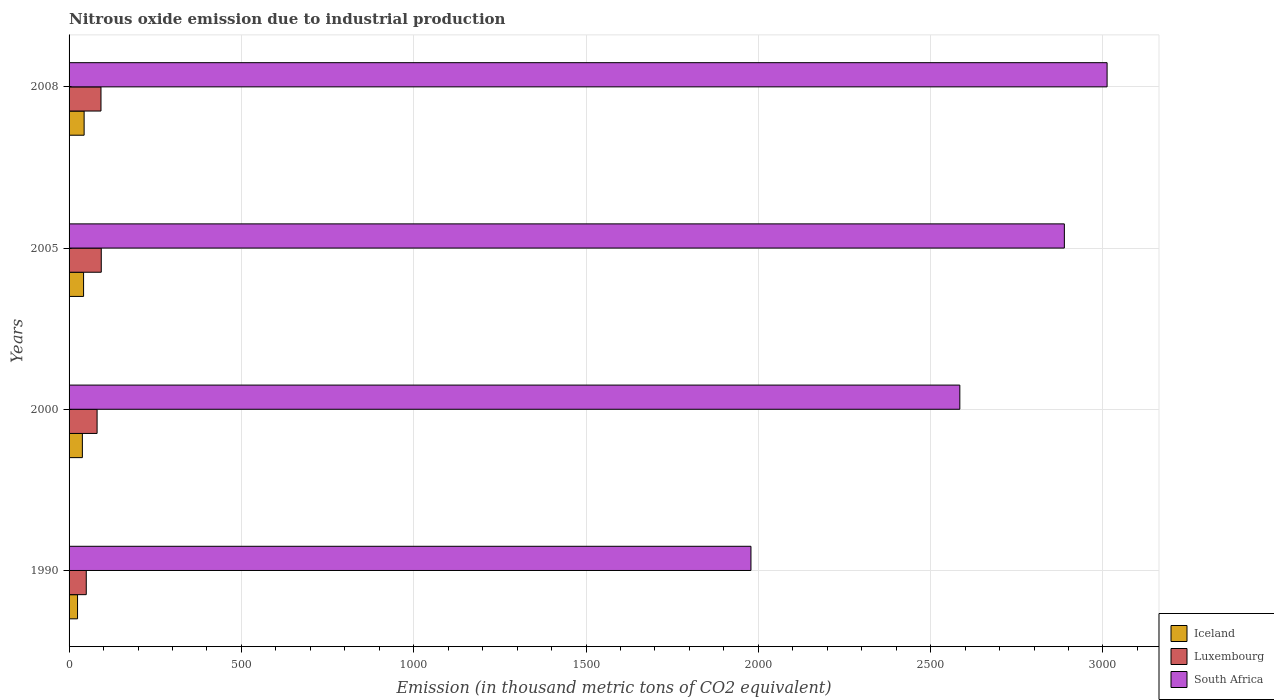How many different coloured bars are there?
Provide a succinct answer. 3. Are the number of bars on each tick of the Y-axis equal?
Offer a terse response. Yes. What is the label of the 3rd group of bars from the top?
Provide a short and direct response. 2000. What is the amount of nitrous oxide emitted in Iceland in 1990?
Give a very brief answer. 24.6. Across all years, what is the maximum amount of nitrous oxide emitted in South Africa?
Your response must be concise. 3012. Across all years, what is the minimum amount of nitrous oxide emitted in South Africa?
Offer a very short reply. 1978.6. In which year was the amount of nitrous oxide emitted in Luxembourg maximum?
Ensure brevity in your answer.  2005. In which year was the amount of nitrous oxide emitted in South Africa minimum?
Provide a succinct answer. 1990. What is the total amount of nitrous oxide emitted in Luxembourg in the graph?
Your response must be concise. 317.2. What is the difference between the amount of nitrous oxide emitted in Iceland in 1990 and that in 2008?
Your response must be concise. -19.1. What is the difference between the amount of nitrous oxide emitted in Luxembourg in 2005 and the amount of nitrous oxide emitted in Iceland in 2000?
Give a very brief answer. 54.8. What is the average amount of nitrous oxide emitted in South Africa per year?
Ensure brevity in your answer.  2615.82. In the year 1990, what is the difference between the amount of nitrous oxide emitted in Luxembourg and amount of nitrous oxide emitted in Iceland?
Provide a short and direct response. 25.3. In how many years, is the amount of nitrous oxide emitted in Iceland greater than 1500 thousand metric tons?
Make the answer very short. 0. What is the ratio of the amount of nitrous oxide emitted in Luxembourg in 2005 to that in 2008?
Your answer should be compact. 1.01. What is the difference between the highest and the second highest amount of nitrous oxide emitted in South Africa?
Offer a very short reply. 124. What is the difference between the highest and the lowest amount of nitrous oxide emitted in Luxembourg?
Offer a terse response. 43.5. What does the 2nd bar from the top in 2005 represents?
Make the answer very short. Luxembourg. What does the 3rd bar from the bottom in 2008 represents?
Offer a very short reply. South Africa. Is it the case that in every year, the sum of the amount of nitrous oxide emitted in Luxembourg and amount of nitrous oxide emitted in Iceland is greater than the amount of nitrous oxide emitted in South Africa?
Make the answer very short. No. How many bars are there?
Your answer should be very brief. 12. What is the difference between two consecutive major ticks on the X-axis?
Offer a very short reply. 500. Are the values on the major ticks of X-axis written in scientific E-notation?
Give a very brief answer. No. Does the graph contain any zero values?
Offer a terse response. No. How many legend labels are there?
Keep it short and to the point. 3. How are the legend labels stacked?
Provide a short and direct response. Vertical. What is the title of the graph?
Offer a terse response. Nitrous oxide emission due to industrial production. Does "Bermuda" appear as one of the legend labels in the graph?
Offer a terse response. No. What is the label or title of the X-axis?
Offer a very short reply. Emission (in thousand metric tons of CO2 equivalent). What is the label or title of the Y-axis?
Your answer should be very brief. Years. What is the Emission (in thousand metric tons of CO2 equivalent) of Iceland in 1990?
Offer a very short reply. 24.6. What is the Emission (in thousand metric tons of CO2 equivalent) in Luxembourg in 1990?
Provide a short and direct response. 49.9. What is the Emission (in thousand metric tons of CO2 equivalent) of South Africa in 1990?
Your answer should be compact. 1978.6. What is the Emission (in thousand metric tons of CO2 equivalent) in Iceland in 2000?
Provide a short and direct response. 38.6. What is the Emission (in thousand metric tons of CO2 equivalent) of Luxembourg in 2000?
Provide a short and direct response. 81.3. What is the Emission (in thousand metric tons of CO2 equivalent) in South Africa in 2000?
Ensure brevity in your answer.  2584.7. What is the Emission (in thousand metric tons of CO2 equivalent) of Iceland in 2005?
Your response must be concise. 42.1. What is the Emission (in thousand metric tons of CO2 equivalent) of Luxembourg in 2005?
Your answer should be compact. 93.4. What is the Emission (in thousand metric tons of CO2 equivalent) in South Africa in 2005?
Provide a short and direct response. 2888. What is the Emission (in thousand metric tons of CO2 equivalent) in Iceland in 2008?
Your response must be concise. 43.7. What is the Emission (in thousand metric tons of CO2 equivalent) in Luxembourg in 2008?
Offer a terse response. 92.6. What is the Emission (in thousand metric tons of CO2 equivalent) of South Africa in 2008?
Make the answer very short. 3012. Across all years, what is the maximum Emission (in thousand metric tons of CO2 equivalent) in Iceland?
Provide a succinct answer. 43.7. Across all years, what is the maximum Emission (in thousand metric tons of CO2 equivalent) of Luxembourg?
Give a very brief answer. 93.4. Across all years, what is the maximum Emission (in thousand metric tons of CO2 equivalent) in South Africa?
Offer a very short reply. 3012. Across all years, what is the minimum Emission (in thousand metric tons of CO2 equivalent) of Iceland?
Your response must be concise. 24.6. Across all years, what is the minimum Emission (in thousand metric tons of CO2 equivalent) in Luxembourg?
Give a very brief answer. 49.9. Across all years, what is the minimum Emission (in thousand metric tons of CO2 equivalent) in South Africa?
Keep it short and to the point. 1978.6. What is the total Emission (in thousand metric tons of CO2 equivalent) in Iceland in the graph?
Provide a short and direct response. 149. What is the total Emission (in thousand metric tons of CO2 equivalent) in Luxembourg in the graph?
Keep it short and to the point. 317.2. What is the total Emission (in thousand metric tons of CO2 equivalent) in South Africa in the graph?
Your response must be concise. 1.05e+04. What is the difference between the Emission (in thousand metric tons of CO2 equivalent) of Luxembourg in 1990 and that in 2000?
Make the answer very short. -31.4. What is the difference between the Emission (in thousand metric tons of CO2 equivalent) of South Africa in 1990 and that in 2000?
Your answer should be compact. -606.1. What is the difference between the Emission (in thousand metric tons of CO2 equivalent) in Iceland in 1990 and that in 2005?
Offer a terse response. -17.5. What is the difference between the Emission (in thousand metric tons of CO2 equivalent) in Luxembourg in 1990 and that in 2005?
Offer a terse response. -43.5. What is the difference between the Emission (in thousand metric tons of CO2 equivalent) in South Africa in 1990 and that in 2005?
Offer a very short reply. -909.4. What is the difference between the Emission (in thousand metric tons of CO2 equivalent) of Iceland in 1990 and that in 2008?
Your answer should be very brief. -19.1. What is the difference between the Emission (in thousand metric tons of CO2 equivalent) in Luxembourg in 1990 and that in 2008?
Make the answer very short. -42.7. What is the difference between the Emission (in thousand metric tons of CO2 equivalent) of South Africa in 1990 and that in 2008?
Give a very brief answer. -1033.4. What is the difference between the Emission (in thousand metric tons of CO2 equivalent) in Luxembourg in 2000 and that in 2005?
Your response must be concise. -12.1. What is the difference between the Emission (in thousand metric tons of CO2 equivalent) in South Africa in 2000 and that in 2005?
Ensure brevity in your answer.  -303.3. What is the difference between the Emission (in thousand metric tons of CO2 equivalent) in Iceland in 2000 and that in 2008?
Your answer should be compact. -5.1. What is the difference between the Emission (in thousand metric tons of CO2 equivalent) of South Africa in 2000 and that in 2008?
Provide a succinct answer. -427.3. What is the difference between the Emission (in thousand metric tons of CO2 equivalent) of Iceland in 2005 and that in 2008?
Provide a succinct answer. -1.6. What is the difference between the Emission (in thousand metric tons of CO2 equivalent) in South Africa in 2005 and that in 2008?
Make the answer very short. -124. What is the difference between the Emission (in thousand metric tons of CO2 equivalent) in Iceland in 1990 and the Emission (in thousand metric tons of CO2 equivalent) in Luxembourg in 2000?
Your answer should be very brief. -56.7. What is the difference between the Emission (in thousand metric tons of CO2 equivalent) in Iceland in 1990 and the Emission (in thousand metric tons of CO2 equivalent) in South Africa in 2000?
Provide a short and direct response. -2560.1. What is the difference between the Emission (in thousand metric tons of CO2 equivalent) of Luxembourg in 1990 and the Emission (in thousand metric tons of CO2 equivalent) of South Africa in 2000?
Keep it short and to the point. -2534.8. What is the difference between the Emission (in thousand metric tons of CO2 equivalent) of Iceland in 1990 and the Emission (in thousand metric tons of CO2 equivalent) of Luxembourg in 2005?
Keep it short and to the point. -68.8. What is the difference between the Emission (in thousand metric tons of CO2 equivalent) of Iceland in 1990 and the Emission (in thousand metric tons of CO2 equivalent) of South Africa in 2005?
Offer a terse response. -2863.4. What is the difference between the Emission (in thousand metric tons of CO2 equivalent) of Luxembourg in 1990 and the Emission (in thousand metric tons of CO2 equivalent) of South Africa in 2005?
Your answer should be compact. -2838.1. What is the difference between the Emission (in thousand metric tons of CO2 equivalent) of Iceland in 1990 and the Emission (in thousand metric tons of CO2 equivalent) of Luxembourg in 2008?
Your answer should be compact. -68. What is the difference between the Emission (in thousand metric tons of CO2 equivalent) in Iceland in 1990 and the Emission (in thousand metric tons of CO2 equivalent) in South Africa in 2008?
Your response must be concise. -2987.4. What is the difference between the Emission (in thousand metric tons of CO2 equivalent) in Luxembourg in 1990 and the Emission (in thousand metric tons of CO2 equivalent) in South Africa in 2008?
Keep it short and to the point. -2962.1. What is the difference between the Emission (in thousand metric tons of CO2 equivalent) in Iceland in 2000 and the Emission (in thousand metric tons of CO2 equivalent) in Luxembourg in 2005?
Offer a very short reply. -54.8. What is the difference between the Emission (in thousand metric tons of CO2 equivalent) of Iceland in 2000 and the Emission (in thousand metric tons of CO2 equivalent) of South Africa in 2005?
Provide a short and direct response. -2849.4. What is the difference between the Emission (in thousand metric tons of CO2 equivalent) of Luxembourg in 2000 and the Emission (in thousand metric tons of CO2 equivalent) of South Africa in 2005?
Keep it short and to the point. -2806.7. What is the difference between the Emission (in thousand metric tons of CO2 equivalent) in Iceland in 2000 and the Emission (in thousand metric tons of CO2 equivalent) in Luxembourg in 2008?
Provide a short and direct response. -54. What is the difference between the Emission (in thousand metric tons of CO2 equivalent) of Iceland in 2000 and the Emission (in thousand metric tons of CO2 equivalent) of South Africa in 2008?
Keep it short and to the point. -2973.4. What is the difference between the Emission (in thousand metric tons of CO2 equivalent) of Luxembourg in 2000 and the Emission (in thousand metric tons of CO2 equivalent) of South Africa in 2008?
Ensure brevity in your answer.  -2930.7. What is the difference between the Emission (in thousand metric tons of CO2 equivalent) in Iceland in 2005 and the Emission (in thousand metric tons of CO2 equivalent) in Luxembourg in 2008?
Ensure brevity in your answer.  -50.5. What is the difference between the Emission (in thousand metric tons of CO2 equivalent) of Iceland in 2005 and the Emission (in thousand metric tons of CO2 equivalent) of South Africa in 2008?
Your response must be concise. -2969.9. What is the difference between the Emission (in thousand metric tons of CO2 equivalent) in Luxembourg in 2005 and the Emission (in thousand metric tons of CO2 equivalent) in South Africa in 2008?
Offer a very short reply. -2918.6. What is the average Emission (in thousand metric tons of CO2 equivalent) in Iceland per year?
Provide a short and direct response. 37.25. What is the average Emission (in thousand metric tons of CO2 equivalent) in Luxembourg per year?
Provide a succinct answer. 79.3. What is the average Emission (in thousand metric tons of CO2 equivalent) of South Africa per year?
Give a very brief answer. 2615.82. In the year 1990, what is the difference between the Emission (in thousand metric tons of CO2 equivalent) in Iceland and Emission (in thousand metric tons of CO2 equivalent) in Luxembourg?
Your response must be concise. -25.3. In the year 1990, what is the difference between the Emission (in thousand metric tons of CO2 equivalent) of Iceland and Emission (in thousand metric tons of CO2 equivalent) of South Africa?
Your answer should be very brief. -1954. In the year 1990, what is the difference between the Emission (in thousand metric tons of CO2 equivalent) of Luxembourg and Emission (in thousand metric tons of CO2 equivalent) of South Africa?
Make the answer very short. -1928.7. In the year 2000, what is the difference between the Emission (in thousand metric tons of CO2 equivalent) in Iceland and Emission (in thousand metric tons of CO2 equivalent) in Luxembourg?
Provide a succinct answer. -42.7. In the year 2000, what is the difference between the Emission (in thousand metric tons of CO2 equivalent) in Iceland and Emission (in thousand metric tons of CO2 equivalent) in South Africa?
Give a very brief answer. -2546.1. In the year 2000, what is the difference between the Emission (in thousand metric tons of CO2 equivalent) in Luxembourg and Emission (in thousand metric tons of CO2 equivalent) in South Africa?
Ensure brevity in your answer.  -2503.4. In the year 2005, what is the difference between the Emission (in thousand metric tons of CO2 equivalent) in Iceland and Emission (in thousand metric tons of CO2 equivalent) in Luxembourg?
Offer a terse response. -51.3. In the year 2005, what is the difference between the Emission (in thousand metric tons of CO2 equivalent) in Iceland and Emission (in thousand metric tons of CO2 equivalent) in South Africa?
Offer a terse response. -2845.9. In the year 2005, what is the difference between the Emission (in thousand metric tons of CO2 equivalent) in Luxembourg and Emission (in thousand metric tons of CO2 equivalent) in South Africa?
Offer a very short reply. -2794.6. In the year 2008, what is the difference between the Emission (in thousand metric tons of CO2 equivalent) in Iceland and Emission (in thousand metric tons of CO2 equivalent) in Luxembourg?
Your answer should be compact. -48.9. In the year 2008, what is the difference between the Emission (in thousand metric tons of CO2 equivalent) of Iceland and Emission (in thousand metric tons of CO2 equivalent) of South Africa?
Your answer should be very brief. -2968.3. In the year 2008, what is the difference between the Emission (in thousand metric tons of CO2 equivalent) in Luxembourg and Emission (in thousand metric tons of CO2 equivalent) in South Africa?
Give a very brief answer. -2919.4. What is the ratio of the Emission (in thousand metric tons of CO2 equivalent) of Iceland in 1990 to that in 2000?
Your answer should be very brief. 0.64. What is the ratio of the Emission (in thousand metric tons of CO2 equivalent) in Luxembourg in 1990 to that in 2000?
Your answer should be compact. 0.61. What is the ratio of the Emission (in thousand metric tons of CO2 equivalent) of South Africa in 1990 to that in 2000?
Offer a very short reply. 0.77. What is the ratio of the Emission (in thousand metric tons of CO2 equivalent) in Iceland in 1990 to that in 2005?
Offer a terse response. 0.58. What is the ratio of the Emission (in thousand metric tons of CO2 equivalent) of Luxembourg in 1990 to that in 2005?
Your response must be concise. 0.53. What is the ratio of the Emission (in thousand metric tons of CO2 equivalent) in South Africa in 1990 to that in 2005?
Give a very brief answer. 0.69. What is the ratio of the Emission (in thousand metric tons of CO2 equivalent) of Iceland in 1990 to that in 2008?
Provide a short and direct response. 0.56. What is the ratio of the Emission (in thousand metric tons of CO2 equivalent) in Luxembourg in 1990 to that in 2008?
Provide a succinct answer. 0.54. What is the ratio of the Emission (in thousand metric tons of CO2 equivalent) of South Africa in 1990 to that in 2008?
Your answer should be compact. 0.66. What is the ratio of the Emission (in thousand metric tons of CO2 equivalent) in Iceland in 2000 to that in 2005?
Offer a terse response. 0.92. What is the ratio of the Emission (in thousand metric tons of CO2 equivalent) in Luxembourg in 2000 to that in 2005?
Your response must be concise. 0.87. What is the ratio of the Emission (in thousand metric tons of CO2 equivalent) of South Africa in 2000 to that in 2005?
Keep it short and to the point. 0.9. What is the ratio of the Emission (in thousand metric tons of CO2 equivalent) of Iceland in 2000 to that in 2008?
Make the answer very short. 0.88. What is the ratio of the Emission (in thousand metric tons of CO2 equivalent) in Luxembourg in 2000 to that in 2008?
Offer a terse response. 0.88. What is the ratio of the Emission (in thousand metric tons of CO2 equivalent) of South Africa in 2000 to that in 2008?
Offer a very short reply. 0.86. What is the ratio of the Emission (in thousand metric tons of CO2 equivalent) in Iceland in 2005 to that in 2008?
Ensure brevity in your answer.  0.96. What is the ratio of the Emission (in thousand metric tons of CO2 equivalent) of Luxembourg in 2005 to that in 2008?
Offer a terse response. 1.01. What is the ratio of the Emission (in thousand metric tons of CO2 equivalent) of South Africa in 2005 to that in 2008?
Offer a very short reply. 0.96. What is the difference between the highest and the second highest Emission (in thousand metric tons of CO2 equivalent) in Luxembourg?
Keep it short and to the point. 0.8. What is the difference between the highest and the second highest Emission (in thousand metric tons of CO2 equivalent) in South Africa?
Offer a terse response. 124. What is the difference between the highest and the lowest Emission (in thousand metric tons of CO2 equivalent) in Iceland?
Your answer should be very brief. 19.1. What is the difference between the highest and the lowest Emission (in thousand metric tons of CO2 equivalent) of Luxembourg?
Provide a short and direct response. 43.5. What is the difference between the highest and the lowest Emission (in thousand metric tons of CO2 equivalent) in South Africa?
Your answer should be compact. 1033.4. 